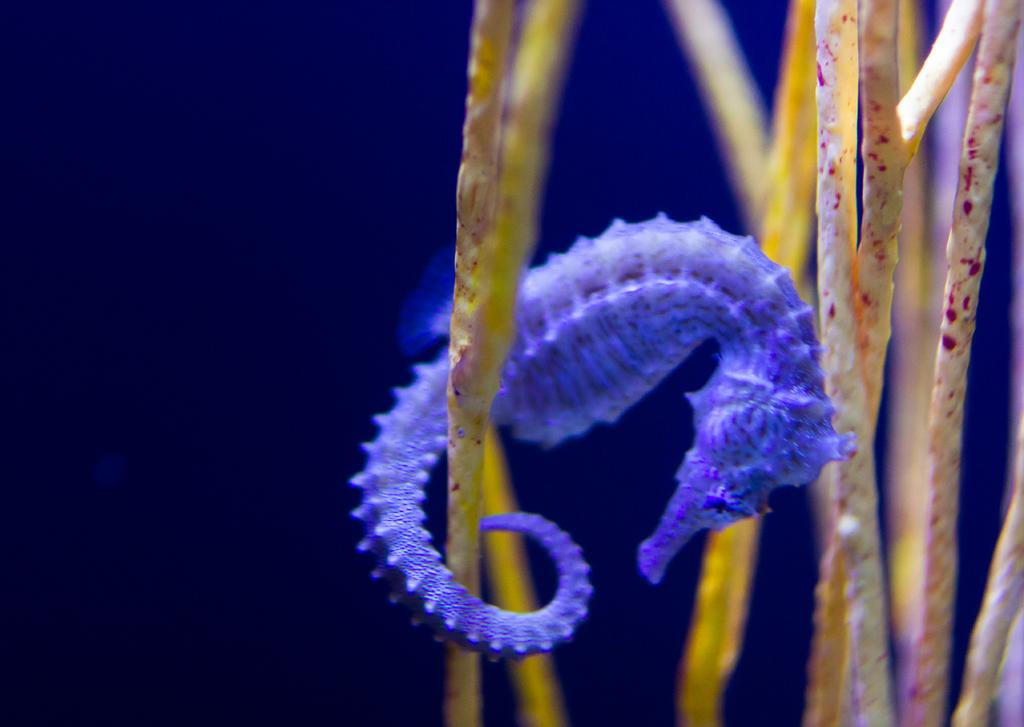What type of animal is in the image? There is a seahorse in the image. What is the environment like in the image? The environment includes water and plants. Where can I buy a seahorse in the image? The image does not depict a shop or any place to purchase a seahorse. 